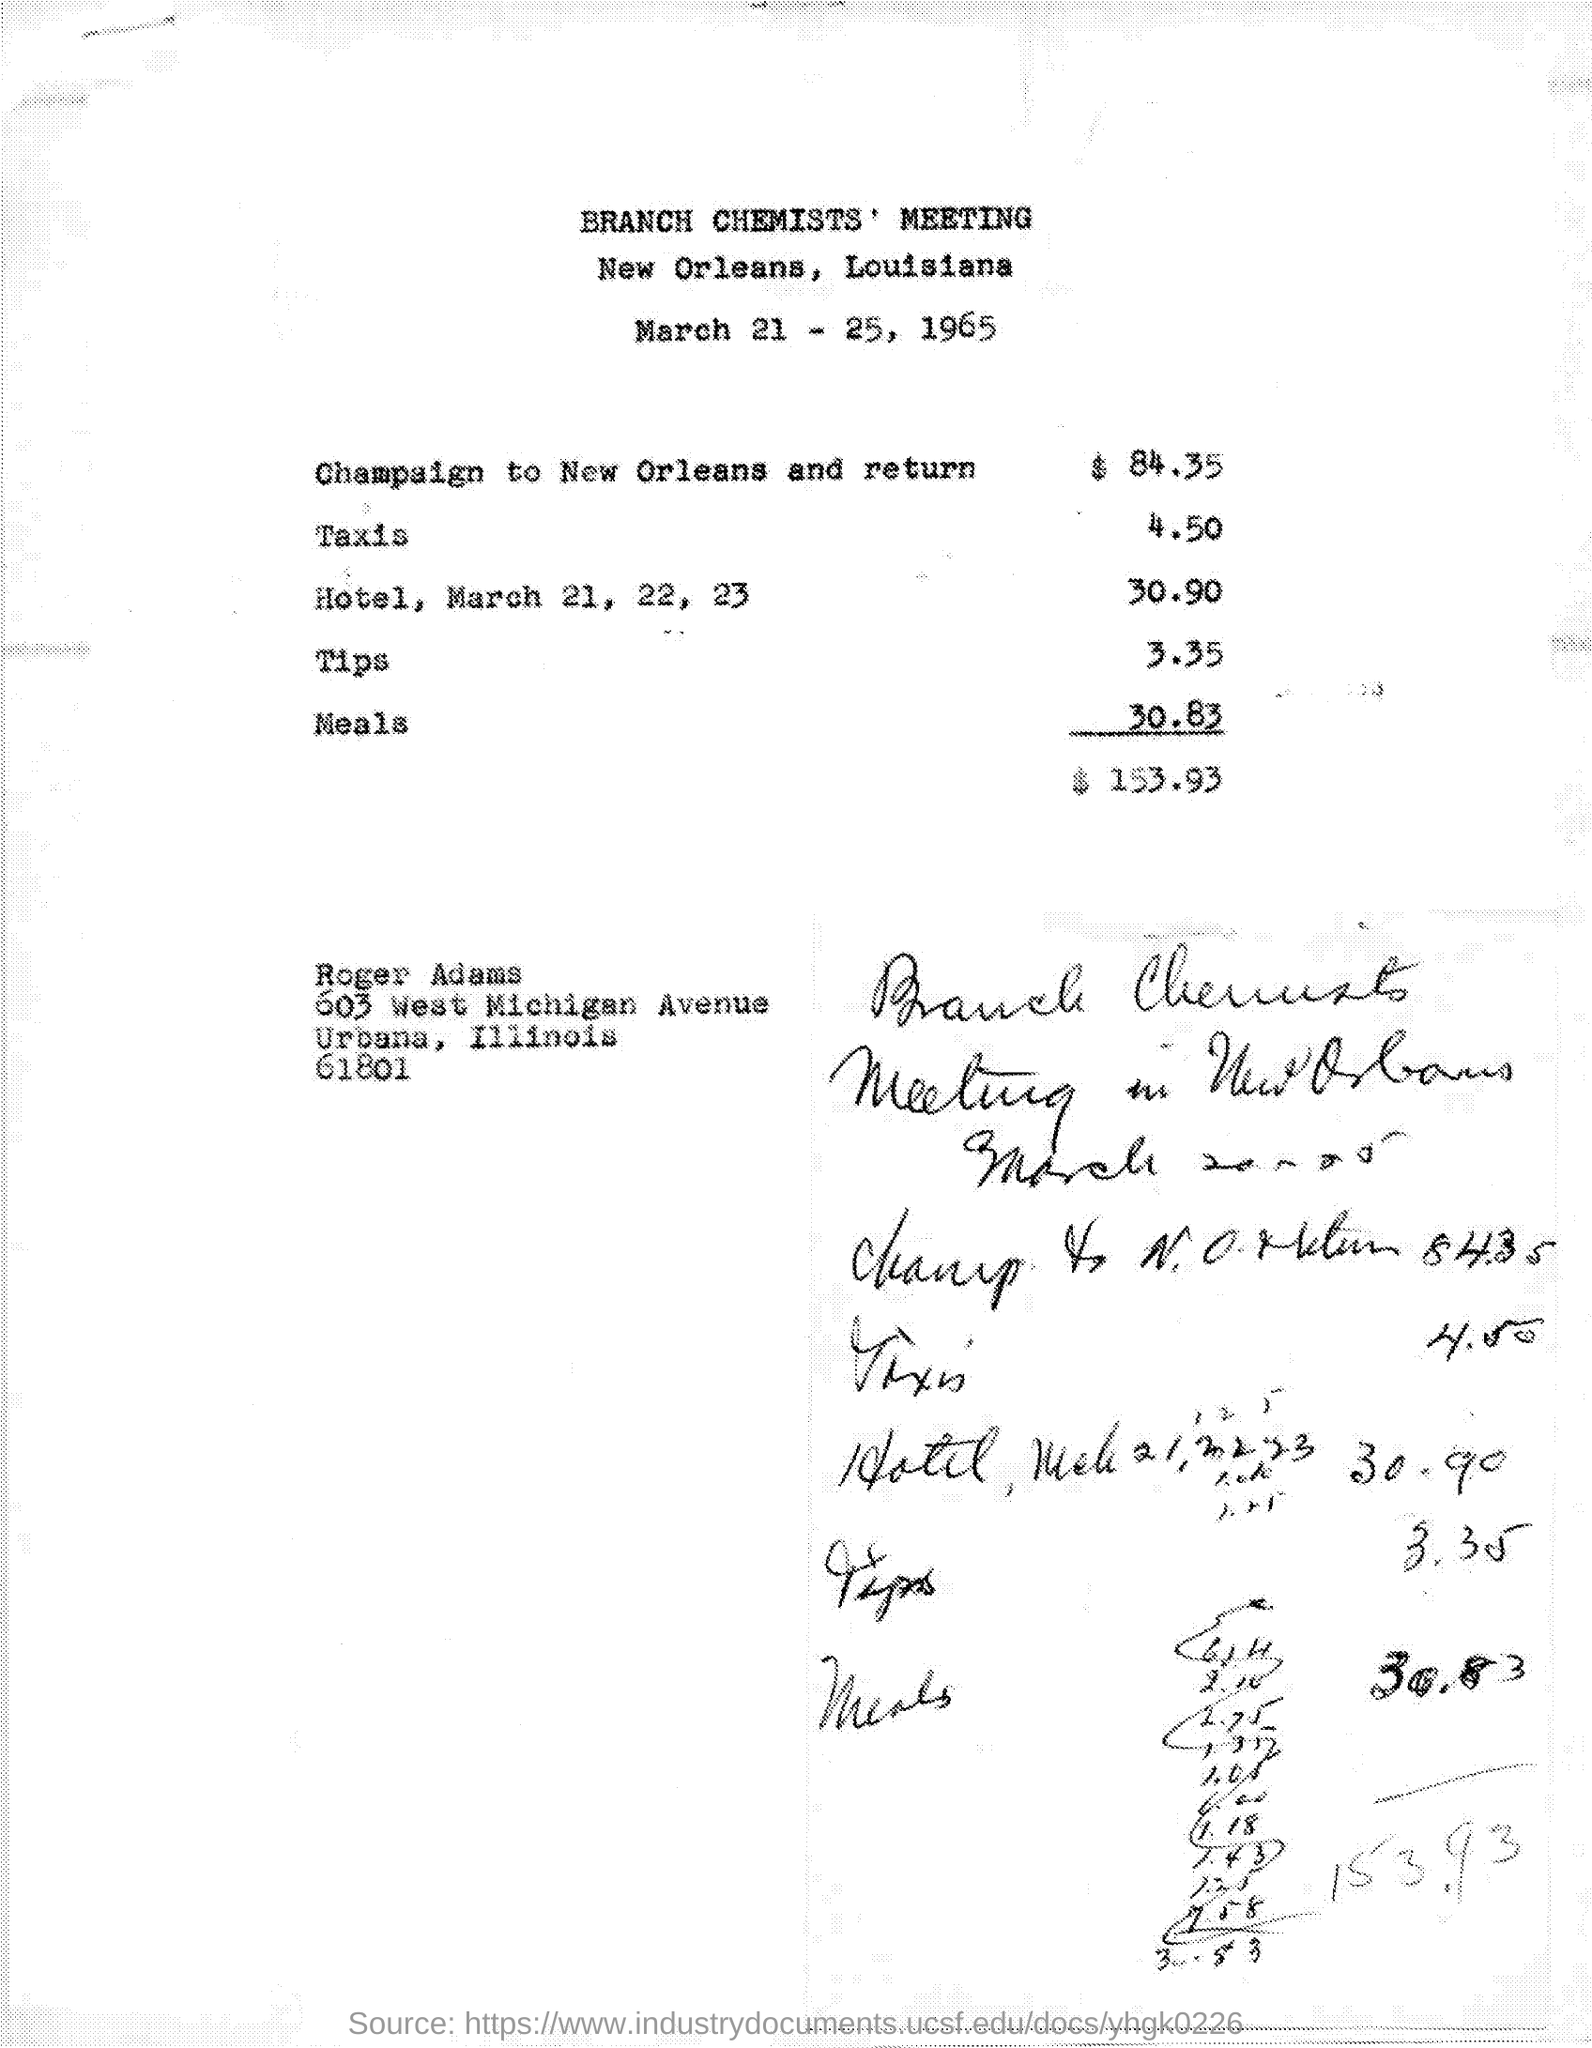List a handful of essential elements in this visual. The cost of meals is 30.83. The expenses for a trip from Champaign to New Orleans and back, as mentioned in the given letter, are 84.35. The cost of taxis is 4.50. The total expenses mentioned in the provided page are $153.93. The expenses for tips mentioned on the given page are 3.35... 